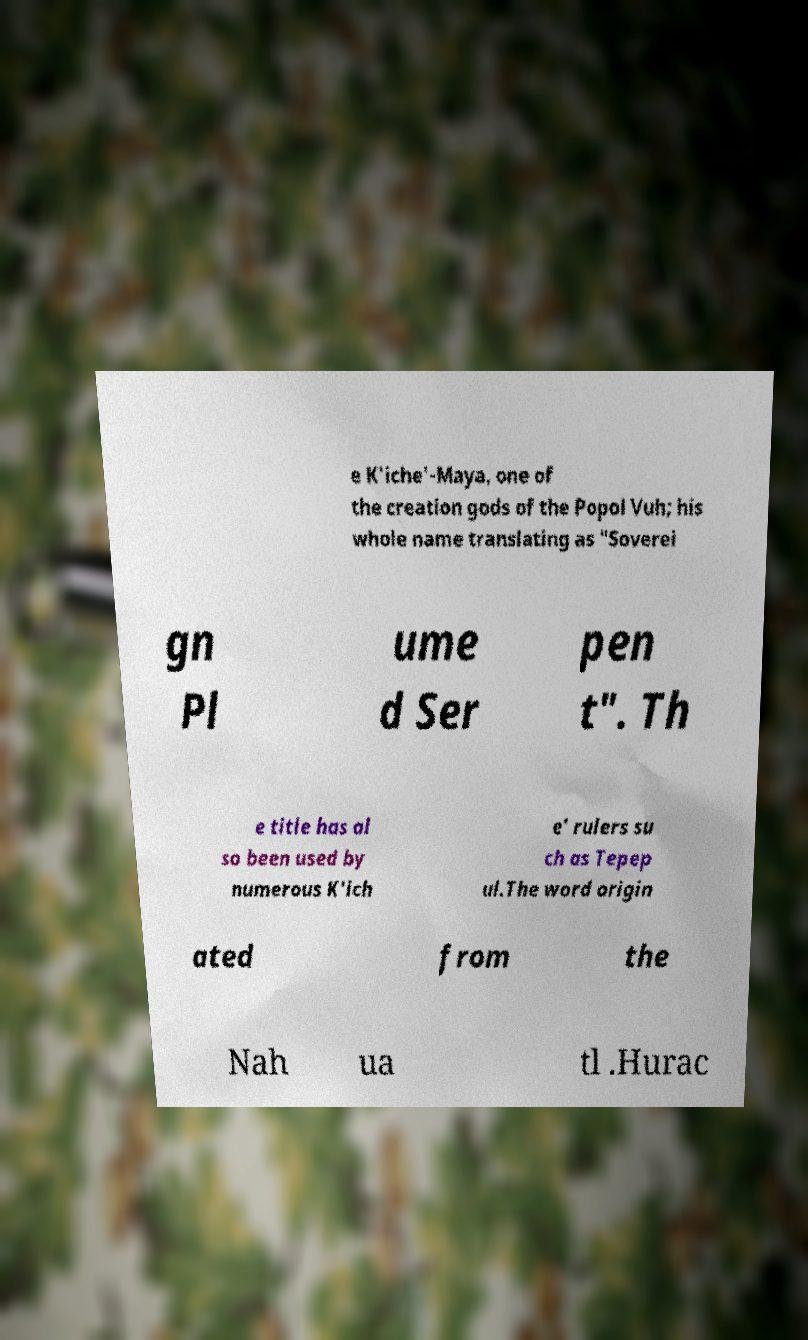Could you extract and type out the text from this image? e K'iche'-Maya, one of the creation gods of the Popol Vuh; his whole name translating as "Soverei gn Pl ume d Ser pen t". Th e title has al so been used by numerous K'ich e' rulers su ch as Tepep ul.The word origin ated from the Nah ua tl .Hurac 